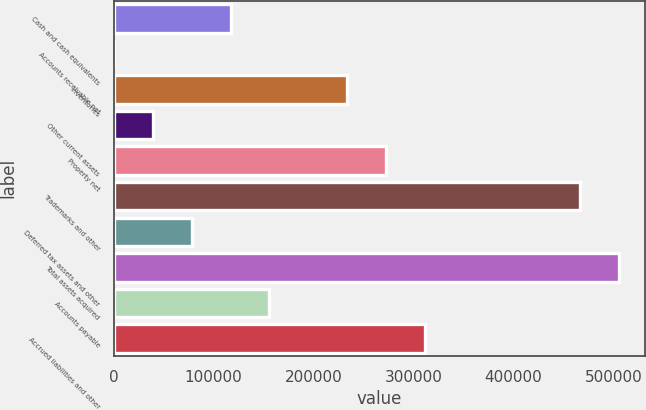<chart> <loc_0><loc_0><loc_500><loc_500><bar_chart><fcel>Cash and cash equivalents<fcel>Accounts receivable net<fcel>Inventories<fcel>Other current assets<fcel>Property net<fcel>Trademarks and other<fcel>Deferred tax assets and other<fcel>Total assets acquired<fcel>Accounts payable<fcel>Accrued liabilities and other<nl><fcel>116899<fcel>197<fcel>233602<fcel>39097.8<fcel>272503<fcel>467007<fcel>77998.6<fcel>505907<fcel>155800<fcel>311403<nl></chart> 